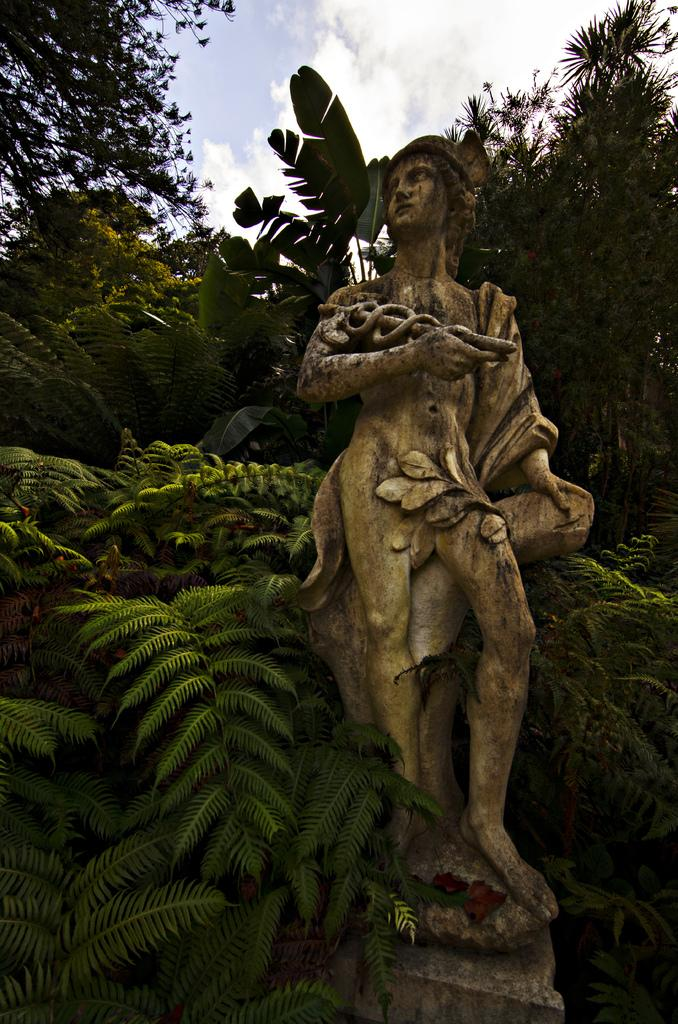What is the main subject of the image? There is a stone sculpture of a person in the image. What can be seen behind the sculpture? There are plants and trees behind the sculpture. What is the condition of the plants and trees? The plants and trees are covered. What is visible above the sculpture? The sky is visible above the sculpture. What can be observed in the sky? Clouds are present in the sky. How many eyes can be seen on the sculpture in the image? The stone sculpture does not have eyes, as it is a sculpture made of stone and not a living being. 